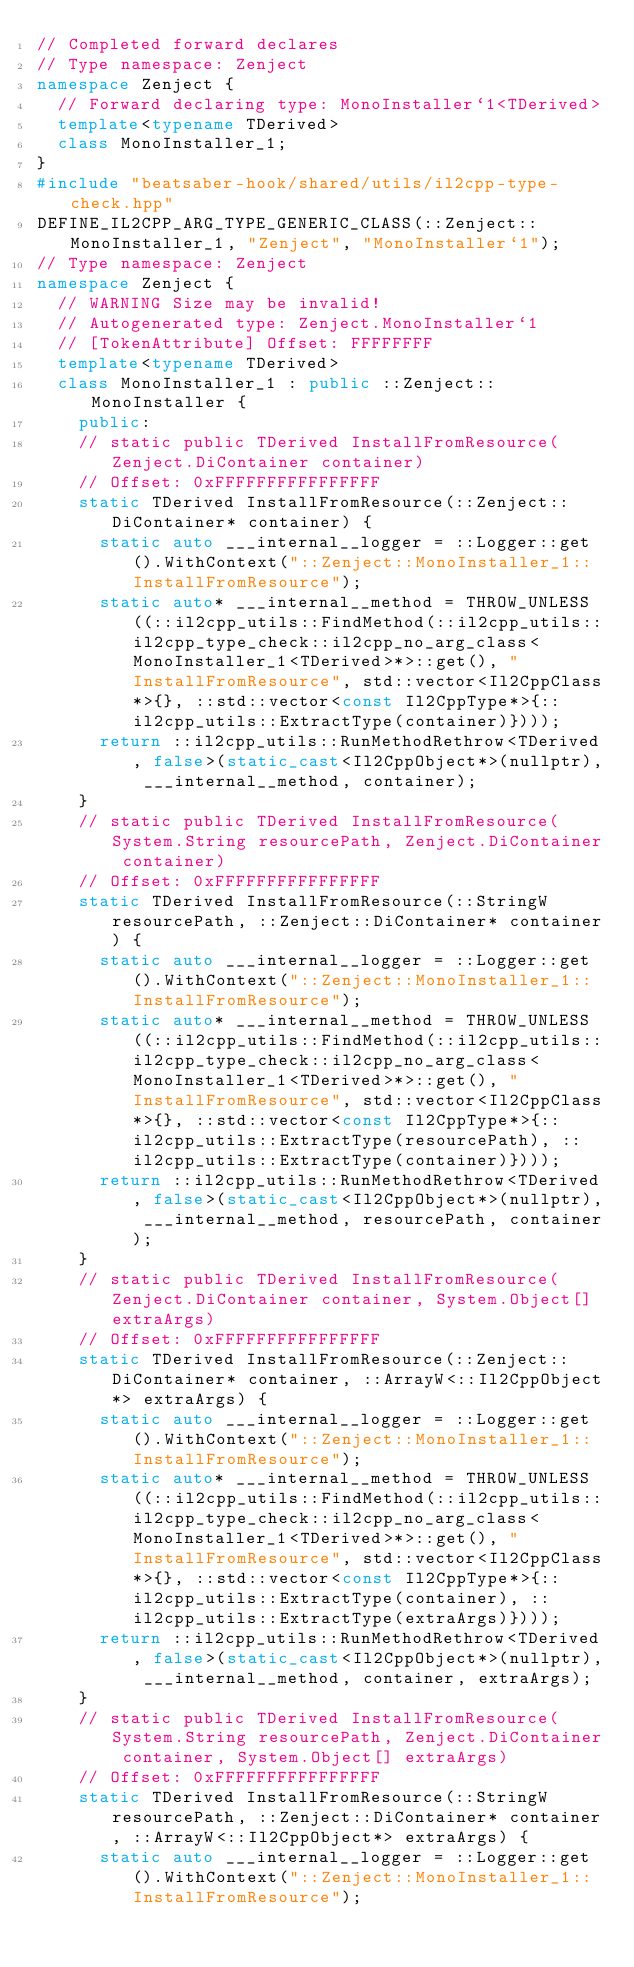Convert code to text. <code><loc_0><loc_0><loc_500><loc_500><_C++_>// Completed forward declares
// Type namespace: Zenject
namespace Zenject {
  // Forward declaring type: MonoInstaller`1<TDerived>
  template<typename TDerived>
  class MonoInstaller_1;
}
#include "beatsaber-hook/shared/utils/il2cpp-type-check.hpp"
DEFINE_IL2CPP_ARG_TYPE_GENERIC_CLASS(::Zenject::MonoInstaller_1, "Zenject", "MonoInstaller`1");
// Type namespace: Zenject
namespace Zenject {
  // WARNING Size may be invalid!
  // Autogenerated type: Zenject.MonoInstaller`1
  // [TokenAttribute] Offset: FFFFFFFF
  template<typename TDerived>
  class MonoInstaller_1 : public ::Zenject::MonoInstaller {
    public:
    // static public TDerived InstallFromResource(Zenject.DiContainer container)
    // Offset: 0xFFFFFFFFFFFFFFFF
    static TDerived InstallFromResource(::Zenject::DiContainer* container) {
      static auto ___internal__logger = ::Logger::get().WithContext("::Zenject::MonoInstaller_1::InstallFromResource");
      static auto* ___internal__method = THROW_UNLESS((::il2cpp_utils::FindMethod(::il2cpp_utils::il2cpp_type_check::il2cpp_no_arg_class<MonoInstaller_1<TDerived>*>::get(), "InstallFromResource", std::vector<Il2CppClass*>{}, ::std::vector<const Il2CppType*>{::il2cpp_utils::ExtractType(container)})));
      return ::il2cpp_utils::RunMethodRethrow<TDerived, false>(static_cast<Il2CppObject*>(nullptr), ___internal__method, container);
    }
    // static public TDerived InstallFromResource(System.String resourcePath, Zenject.DiContainer container)
    // Offset: 0xFFFFFFFFFFFFFFFF
    static TDerived InstallFromResource(::StringW resourcePath, ::Zenject::DiContainer* container) {
      static auto ___internal__logger = ::Logger::get().WithContext("::Zenject::MonoInstaller_1::InstallFromResource");
      static auto* ___internal__method = THROW_UNLESS((::il2cpp_utils::FindMethod(::il2cpp_utils::il2cpp_type_check::il2cpp_no_arg_class<MonoInstaller_1<TDerived>*>::get(), "InstallFromResource", std::vector<Il2CppClass*>{}, ::std::vector<const Il2CppType*>{::il2cpp_utils::ExtractType(resourcePath), ::il2cpp_utils::ExtractType(container)})));
      return ::il2cpp_utils::RunMethodRethrow<TDerived, false>(static_cast<Il2CppObject*>(nullptr), ___internal__method, resourcePath, container);
    }
    // static public TDerived InstallFromResource(Zenject.DiContainer container, System.Object[] extraArgs)
    // Offset: 0xFFFFFFFFFFFFFFFF
    static TDerived InstallFromResource(::Zenject::DiContainer* container, ::ArrayW<::Il2CppObject*> extraArgs) {
      static auto ___internal__logger = ::Logger::get().WithContext("::Zenject::MonoInstaller_1::InstallFromResource");
      static auto* ___internal__method = THROW_UNLESS((::il2cpp_utils::FindMethod(::il2cpp_utils::il2cpp_type_check::il2cpp_no_arg_class<MonoInstaller_1<TDerived>*>::get(), "InstallFromResource", std::vector<Il2CppClass*>{}, ::std::vector<const Il2CppType*>{::il2cpp_utils::ExtractType(container), ::il2cpp_utils::ExtractType(extraArgs)})));
      return ::il2cpp_utils::RunMethodRethrow<TDerived, false>(static_cast<Il2CppObject*>(nullptr), ___internal__method, container, extraArgs);
    }
    // static public TDerived InstallFromResource(System.String resourcePath, Zenject.DiContainer container, System.Object[] extraArgs)
    // Offset: 0xFFFFFFFFFFFFFFFF
    static TDerived InstallFromResource(::StringW resourcePath, ::Zenject::DiContainer* container, ::ArrayW<::Il2CppObject*> extraArgs) {
      static auto ___internal__logger = ::Logger::get().WithContext("::Zenject::MonoInstaller_1::InstallFromResource");</code> 